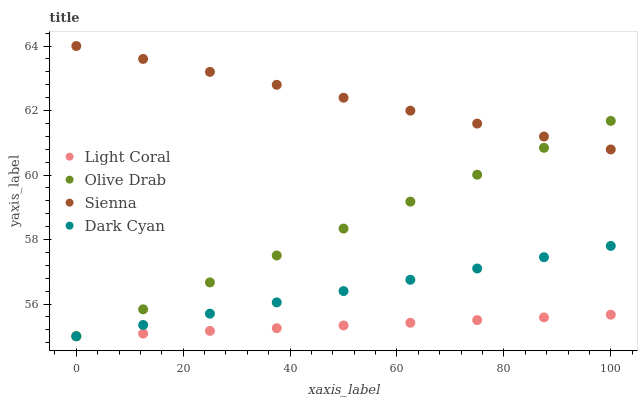Does Light Coral have the minimum area under the curve?
Answer yes or no. Yes. Does Sienna have the maximum area under the curve?
Answer yes or no. Yes. Does Dark Cyan have the minimum area under the curve?
Answer yes or no. No. Does Dark Cyan have the maximum area under the curve?
Answer yes or no. No. Is Dark Cyan the smoothest?
Answer yes or no. Yes. Is Sienna the roughest?
Answer yes or no. Yes. Is Sienna the smoothest?
Answer yes or no. No. Is Dark Cyan the roughest?
Answer yes or no. No. Does Light Coral have the lowest value?
Answer yes or no. Yes. Does Sienna have the lowest value?
Answer yes or no. No. Does Sienna have the highest value?
Answer yes or no. Yes. Does Dark Cyan have the highest value?
Answer yes or no. No. Is Dark Cyan less than Sienna?
Answer yes or no. Yes. Is Sienna greater than Dark Cyan?
Answer yes or no. Yes. Does Olive Drab intersect Light Coral?
Answer yes or no. Yes. Is Olive Drab less than Light Coral?
Answer yes or no. No. Is Olive Drab greater than Light Coral?
Answer yes or no. No. Does Dark Cyan intersect Sienna?
Answer yes or no. No. 